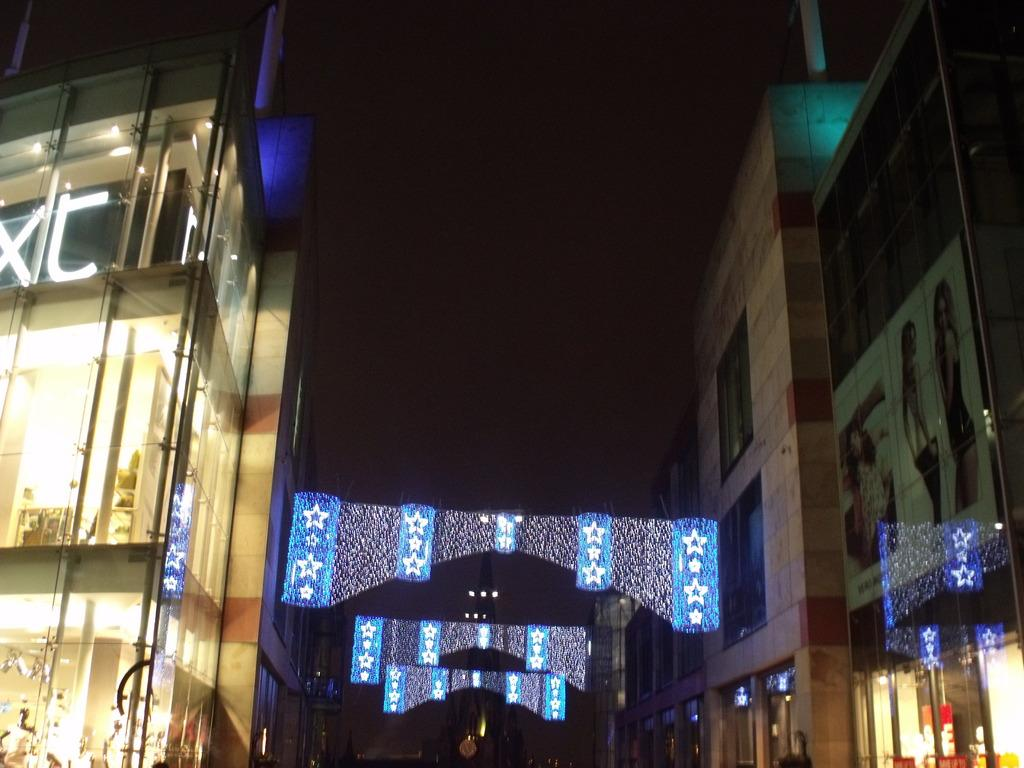What type of structures can be seen on the sides of the image? There are buildings on the sides of the image. Can you describe the building on the left side of the image? The building on the left side of the image has glass walls and pipes. What can be seen in the background of the image? There is decoration with lights in the background of the image. What type of fish is swimming in the haircut of the person in the image? There is no person or haircut present in the image, and therefore no fish swimming in a haircut. 